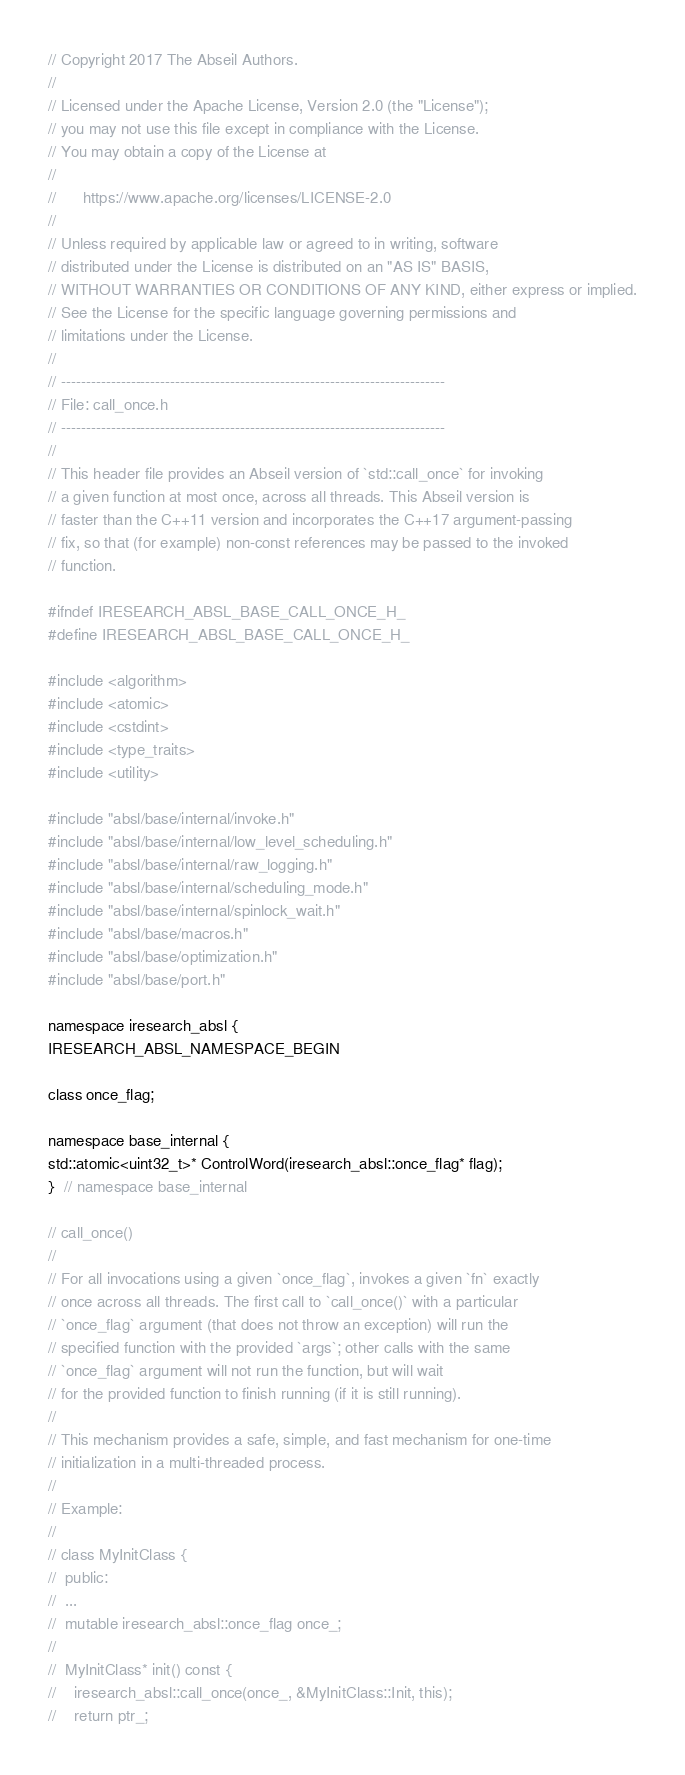<code> <loc_0><loc_0><loc_500><loc_500><_C_>// Copyright 2017 The Abseil Authors.
//
// Licensed under the Apache License, Version 2.0 (the "License");
// you may not use this file except in compliance with the License.
// You may obtain a copy of the License at
//
//      https://www.apache.org/licenses/LICENSE-2.0
//
// Unless required by applicable law or agreed to in writing, software
// distributed under the License is distributed on an "AS IS" BASIS,
// WITHOUT WARRANTIES OR CONDITIONS OF ANY KIND, either express or implied.
// See the License for the specific language governing permissions and
// limitations under the License.
//
// -----------------------------------------------------------------------------
// File: call_once.h
// -----------------------------------------------------------------------------
//
// This header file provides an Abseil version of `std::call_once` for invoking
// a given function at most once, across all threads. This Abseil version is
// faster than the C++11 version and incorporates the C++17 argument-passing
// fix, so that (for example) non-const references may be passed to the invoked
// function.

#ifndef IRESEARCH_ABSL_BASE_CALL_ONCE_H_
#define IRESEARCH_ABSL_BASE_CALL_ONCE_H_

#include <algorithm>
#include <atomic>
#include <cstdint>
#include <type_traits>
#include <utility>

#include "absl/base/internal/invoke.h"
#include "absl/base/internal/low_level_scheduling.h"
#include "absl/base/internal/raw_logging.h"
#include "absl/base/internal/scheduling_mode.h"
#include "absl/base/internal/spinlock_wait.h"
#include "absl/base/macros.h"
#include "absl/base/optimization.h"
#include "absl/base/port.h"

namespace iresearch_absl {
IRESEARCH_ABSL_NAMESPACE_BEGIN

class once_flag;

namespace base_internal {
std::atomic<uint32_t>* ControlWord(iresearch_absl::once_flag* flag);
}  // namespace base_internal

// call_once()
//
// For all invocations using a given `once_flag`, invokes a given `fn` exactly
// once across all threads. The first call to `call_once()` with a particular
// `once_flag` argument (that does not throw an exception) will run the
// specified function with the provided `args`; other calls with the same
// `once_flag` argument will not run the function, but will wait
// for the provided function to finish running (if it is still running).
//
// This mechanism provides a safe, simple, and fast mechanism for one-time
// initialization in a multi-threaded process.
//
// Example:
//
// class MyInitClass {
//  public:
//  ...
//  mutable iresearch_absl::once_flag once_;
//
//  MyInitClass* init() const {
//    iresearch_absl::call_once(once_, &MyInitClass::Init, this);
//    return ptr_;</code> 